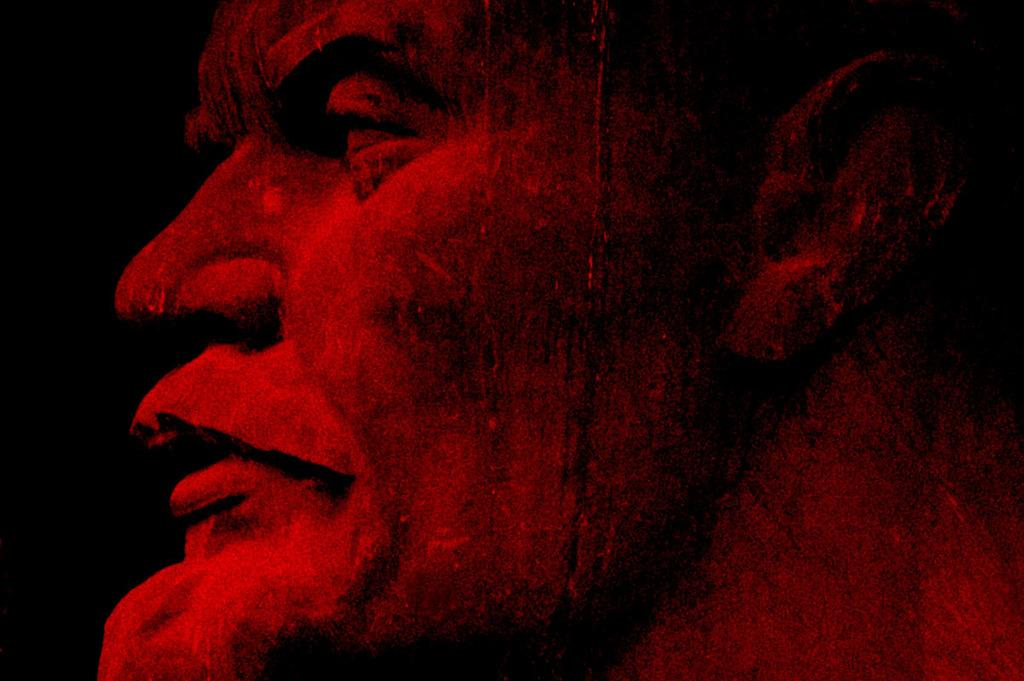What is the main subject of the image? There is a depiction of a person in the image. What color is the background of the image? The background of the image is black in color. How many circles can be seen in the image? There are no circles present in the image. Is the person in the image wearing a shirt? The provided facts do not mention anything about the person's clothing, so it cannot be determined from the image. 